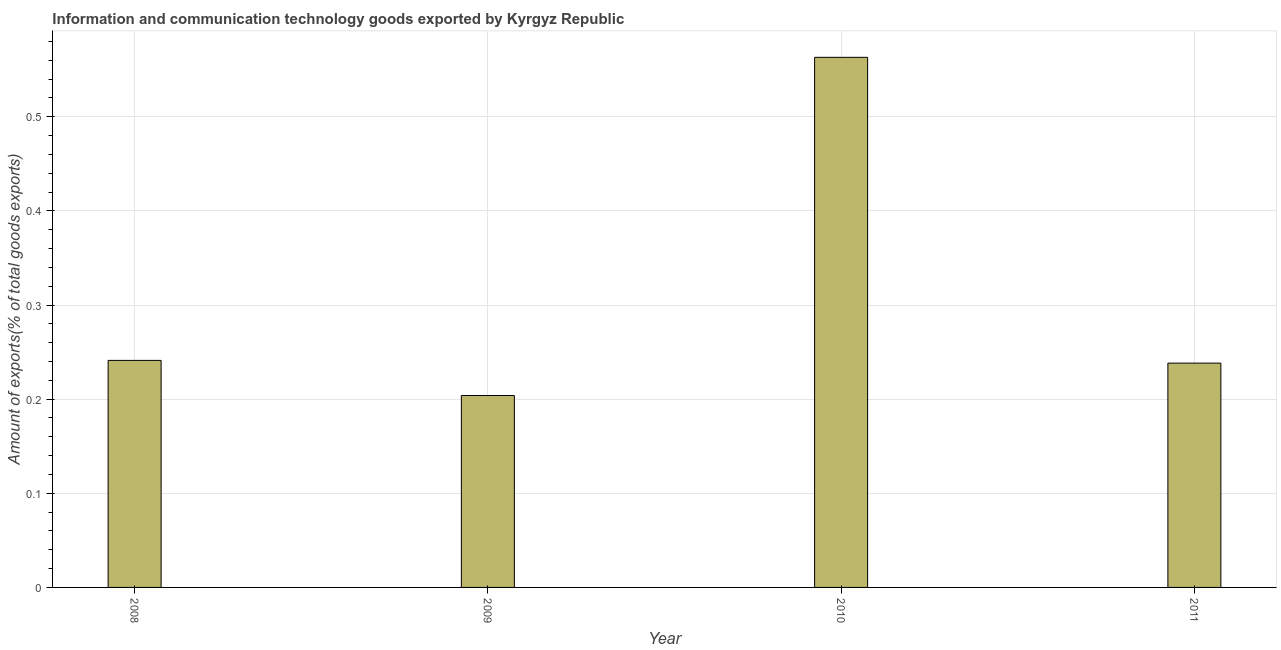Does the graph contain grids?
Provide a short and direct response. Yes. What is the title of the graph?
Give a very brief answer. Information and communication technology goods exported by Kyrgyz Republic. What is the label or title of the Y-axis?
Offer a terse response. Amount of exports(% of total goods exports). What is the amount of ict goods exports in 2009?
Give a very brief answer. 0.2. Across all years, what is the maximum amount of ict goods exports?
Ensure brevity in your answer.  0.56. Across all years, what is the minimum amount of ict goods exports?
Your response must be concise. 0.2. In which year was the amount of ict goods exports maximum?
Offer a very short reply. 2010. In which year was the amount of ict goods exports minimum?
Offer a terse response. 2009. What is the sum of the amount of ict goods exports?
Provide a succinct answer. 1.25. What is the difference between the amount of ict goods exports in 2008 and 2011?
Offer a very short reply. 0. What is the average amount of ict goods exports per year?
Give a very brief answer. 0.31. What is the median amount of ict goods exports?
Offer a terse response. 0.24. In how many years, is the amount of ict goods exports greater than 0.52 %?
Offer a very short reply. 1. What is the ratio of the amount of ict goods exports in 2009 to that in 2011?
Provide a succinct answer. 0.86. Is the amount of ict goods exports in 2008 less than that in 2010?
Provide a short and direct response. Yes. Is the difference between the amount of ict goods exports in 2010 and 2011 greater than the difference between any two years?
Your answer should be compact. No. What is the difference between the highest and the second highest amount of ict goods exports?
Your answer should be compact. 0.32. Is the sum of the amount of ict goods exports in 2009 and 2010 greater than the maximum amount of ict goods exports across all years?
Provide a short and direct response. Yes. What is the difference between the highest and the lowest amount of ict goods exports?
Provide a succinct answer. 0.36. How many bars are there?
Provide a succinct answer. 4. What is the Amount of exports(% of total goods exports) of 2008?
Give a very brief answer. 0.24. What is the Amount of exports(% of total goods exports) of 2009?
Make the answer very short. 0.2. What is the Amount of exports(% of total goods exports) of 2010?
Provide a succinct answer. 0.56. What is the Amount of exports(% of total goods exports) in 2011?
Ensure brevity in your answer.  0.24. What is the difference between the Amount of exports(% of total goods exports) in 2008 and 2009?
Give a very brief answer. 0.04. What is the difference between the Amount of exports(% of total goods exports) in 2008 and 2010?
Ensure brevity in your answer.  -0.32. What is the difference between the Amount of exports(% of total goods exports) in 2008 and 2011?
Your answer should be very brief. 0. What is the difference between the Amount of exports(% of total goods exports) in 2009 and 2010?
Your answer should be very brief. -0.36. What is the difference between the Amount of exports(% of total goods exports) in 2009 and 2011?
Your answer should be compact. -0.03. What is the difference between the Amount of exports(% of total goods exports) in 2010 and 2011?
Offer a very short reply. 0.32. What is the ratio of the Amount of exports(% of total goods exports) in 2008 to that in 2009?
Your answer should be very brief. 1.18. What is the ratio of the Amount of exports(% of total goods exports) in 2008 to that in 2010?
Make the answer very short. 0.43. What is the ratio of the Amount of exports(% of total goods exports) in 2008 to that in 2011?
Provide a succinct answer. 1.01. What is the ratio of the Amount of exports(% of total goods exports) in 2009 to that in 2010?
Provide a succinct answer. 0.36. What is the ratio of the Amount of exports(% of total goods exports) in 2009 to that in 2011?
Your answer should be very brief. 0.86. What is the ratio of the Amount of exports(% of total goods exports) in 2010 to that in 2011?
Provide a succinct answer. 2.36. 